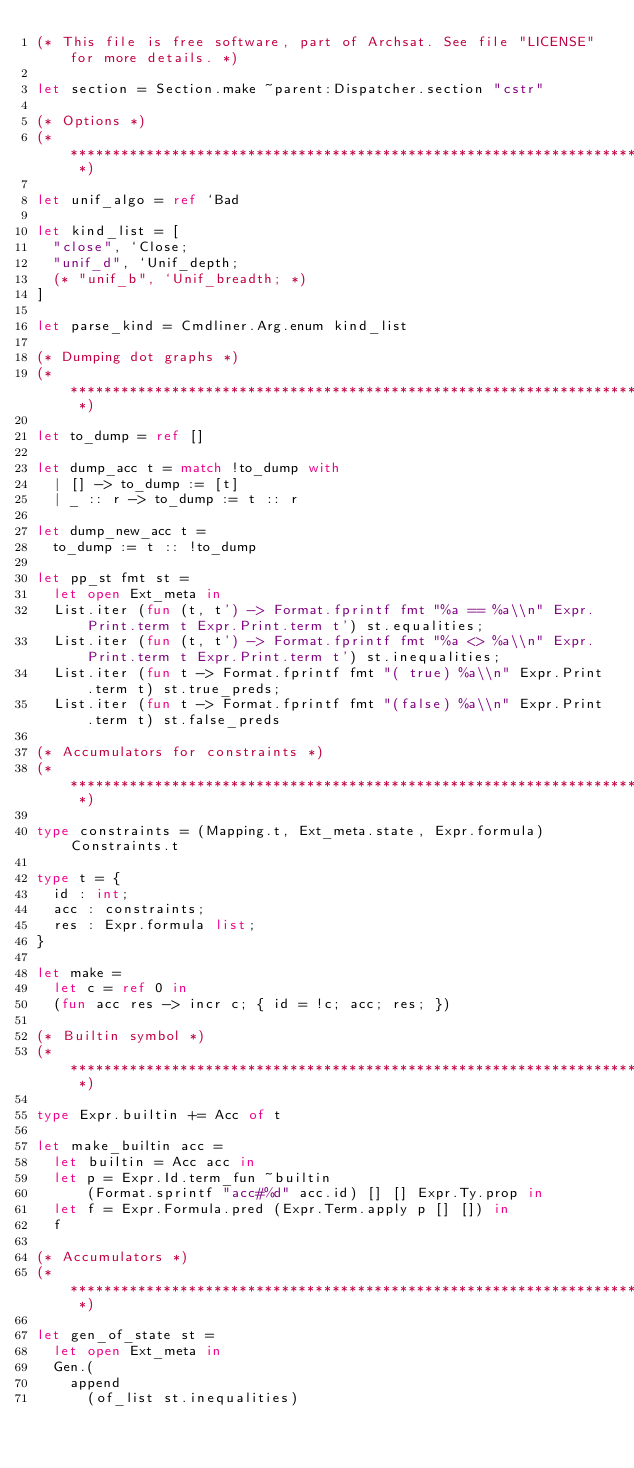<code> <loc_0><loc_0><loc_500><loc_500><_OCaml_>(* This file is free software, part of Archsat. See file "LICENSE" for more details. *)

let section = Section.make ~parent:Dispatcher.section "cstr"

(* Options *)
(* ************************************************************************ *)

let unif_algo = ref `Bad

let kind_list = [
  "close", `Close;
  "unif_d", `Unif_depth;
  (* "unif_b", `Unif_breadth; *)
]

let parse_kind = Cmdliner.Arg.enum kind_list

(* Dumping dot graphs *)
(* ************************************************************************ *)

let to_dump = ref []

let dump_acc t = match !to_dump with
  | [] -> to_dump := [t]
  | _ :: r -> to_dump := t :: r

let dump_new_acc t =
  to_dump := t :: !to_dump

let pp_st fmt st =
  let open Ext_meta in
  List.iter (fun (t, t') -> Format.fprintf fmt "%a == %a\\n" Expr.Print.term t Expr.Print.term t') st.equalities;
  List.iter (fun (t, t') -> Format.fprintf fmt "%a <> %a\\n" Expr.Print.term t Expr.Print.term t') st.inequalities;
  List.iter (fun t -> Format.fprintf fmt "( true) %a\\n" Expr.Print.term t) st.true_preds;
  List.iter (fun t -> Format.fprintf fmt "(false) %a\\n" Expr.Print.term t) st.false_preds

(* Accumulators for constraints *)
(* ************************************************************************ *)

type constraints = (Mapping.t, Ext_meta.state, Expr.formula) Constraints.t

type t = {
  id : int;
  acc : constraints;
  res : Expr.formula list;
}

let make =
  let c = ref 0 in
  (fun acc res -> incr c; { id = !c; acc; res; })

(* Builtin symbol *)
(* ************************************************************************ *)

type Expr.builtin += Acc of t

let make_builtin acc =
  let builtin = Acc acc in
  let p = Expr.Id.term_fun ~builtin
      (Format.sprintf "acc#%d" acc.id) [] [] Expr.Ty.prop in
  let f = Expr.Formula.pred (Expr.Term.apply p [] []) in
  f

(* Accumulators *)
(* ************************************************************************ *)

let gen_of_state st =
  let open Ext_meta in
  Gen.(
    append
      (of_list st.inequalities)</code> 